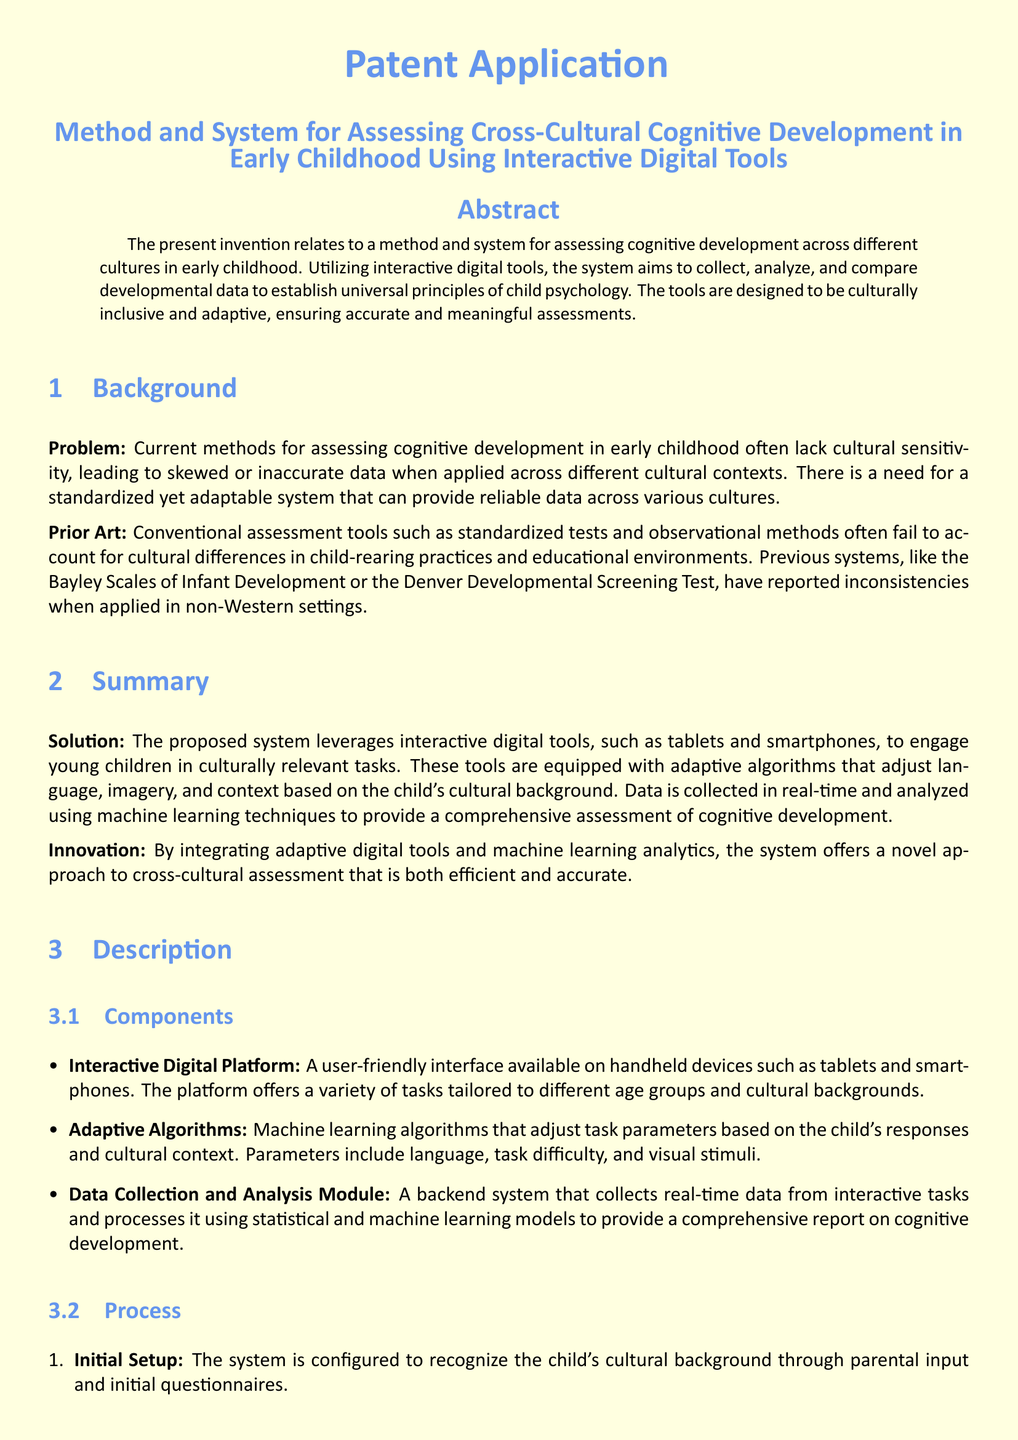What is the title of the patent application? The title of the patent application is listed at the beginning of the document.
Answer: Method and System for Assessing Cross-Cultural Cognitive Development in Early Childhood Using Interactive Digital Tools What is the primary problem addressed in the patent application? The problem statement is highlighted in the Background section of the document.
Answer: Lack of cultural sensitivity What types of devices are mentioned for the interactive digital platform? The document specifies the types of devices that the platform is available on in the Components section.
Answer: Tablets and smartphones What unique feature do the adaptive algorithms provide? The document describes what the adaptive algorithms adjust in the Summary section.
Answer: Task parameters How many steps are outlined in the process of the method? The number of steps is mentioned in the Process subsection of the Description section.
Answer: Four What is the main benefit of using interactive digital tools according to the document? The document suggests the main benefit in the Summary, mentioning efficiency and accuracy.
Answer: Efficient and accurate What is the purpose of the data analysis module? The function of the data analysis module is detailed in the Components subsection of the Description section.
Answer: Generate a developmental profile What is the intended outcome of the proposed system? The intended outcome is discussed in the Summary section of the document.
Answer: Establish universal principles of child psychology 